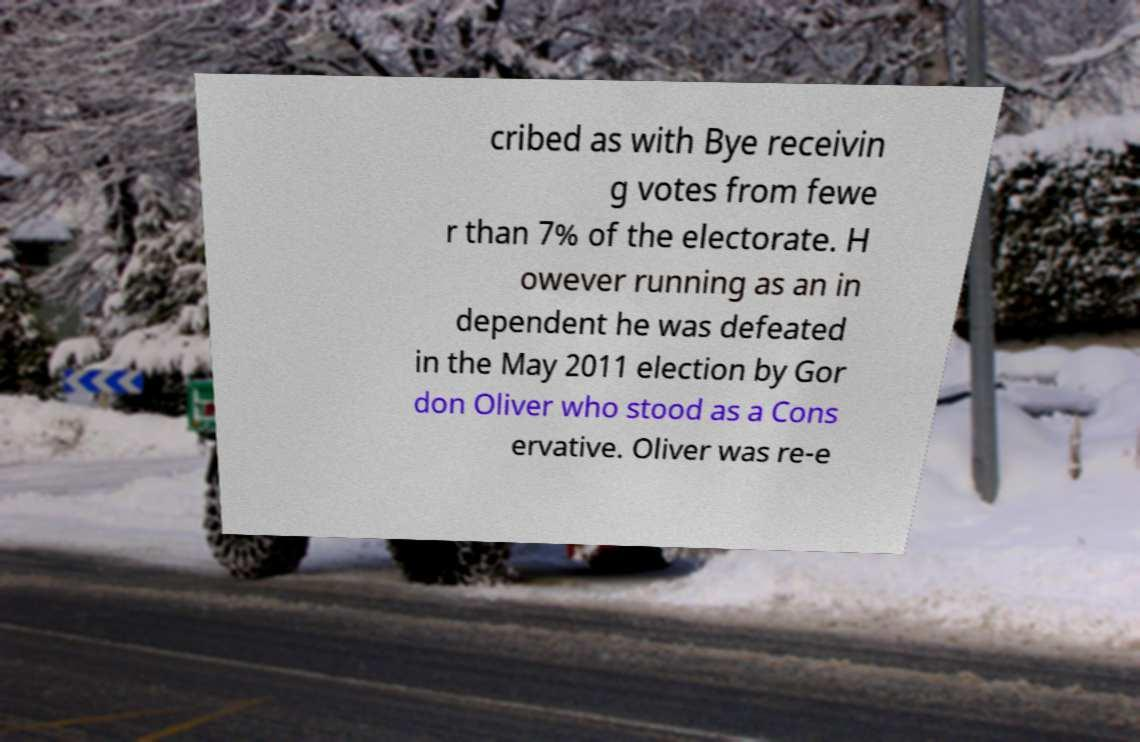Please identify and transcribe the text found in this image. cribed as with Bye receivin g votes from fewe r than 7% of the electorate. H owever running as an in dependent he was defeated in the May 2011 election by Gor don Oliver who stood as a Cons ervative. Oliver was re-e 